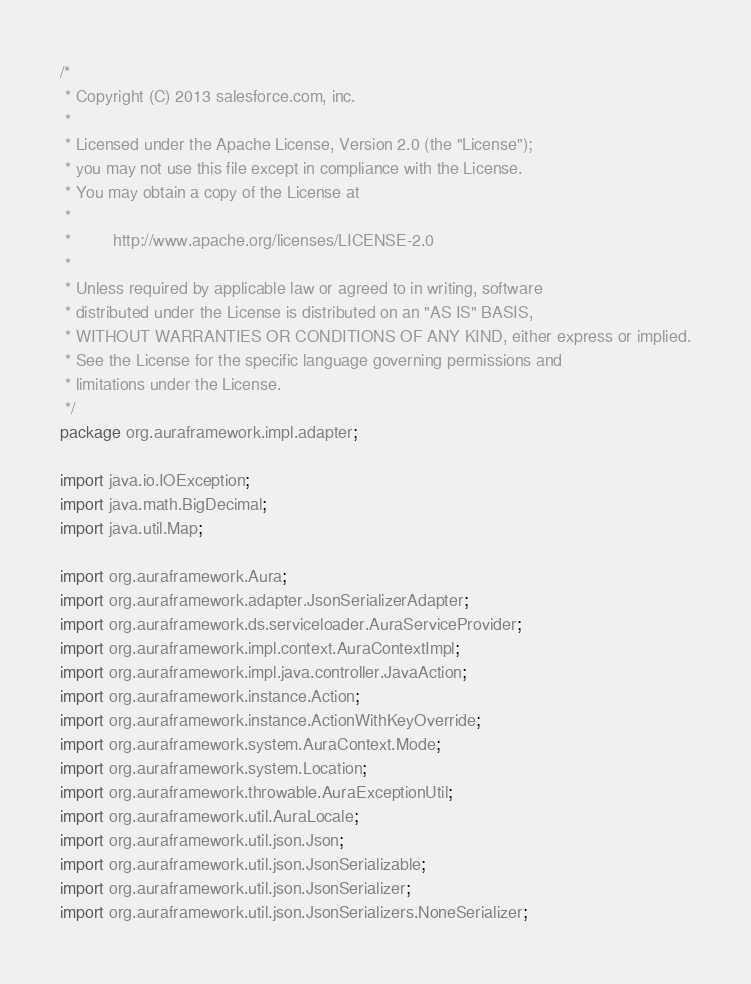Convert code to text. <code><loc_0><loc_0><loc_500><loc_500><_Java_>/*
 * Copyright (C) 2013 salesforce.com, inc.
 *
 * Licensed under the Apache License, Version 2.0 (the "License");
 * you may not use this file except in compliance with the License.
 * You may obtain a copy of the License at
 *
 *         http://www.apache.org/licenses/LICENSE-2.0
 *
 * Unless required by applicable law or agreed to in writing, software
 * distributed under the License is distributed on an "AS IS" BASIS,
 * WITHOUT WARRANTIES OR CONDITIONS OF ANY KIND, either express or implied.
 * See the License for the specific language governing permissions and
 * limitations under the License.
 */
package org.auraframework.impl.adapter;

import java.io.IOException;
import java.math.BigDecimal;
import java.util.Map;

import org.auraframework.Aura;
import org.auraframework.adapter.JsonSerializerAdapter;
import org.auraframework.ds.serviceloader.AuraServiceProvider;
import org.auraframework.impl.context.AuraContextImpl;
import org.auraframework.impl.java.controller.JavaAction;
import org.auraframework.instance.Action;
import org.auraframework.instance.ActionWithKeyOverride;
import org.auraframework.system.AuraContext.Mode;
import org.auraframework.system.Location;
import org.auraframework.throwable.AuraExceptionUtil;
import org.auraframework.util.AuraLocale;
import org.auraframework.util.json.Json;
import org.auraframework.util.json.JsonSerializable;
import org.auraframework.util.json.JsonSerializer;
import org.auraframework.util.json.JsonSerializers.NoneSerializer;</code> 